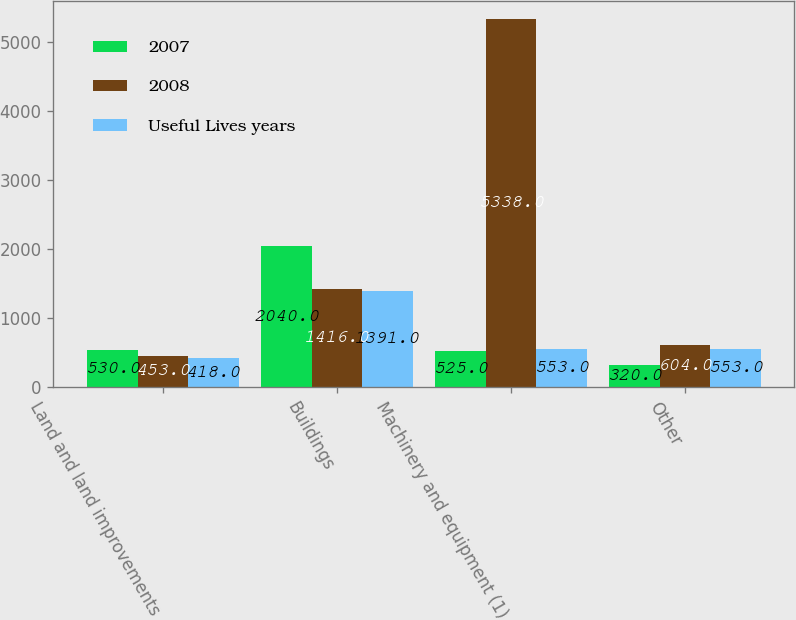Convert chart to OTSL. <chart><loc_0><loc_0><loc_500><loc_500><stacked_bar_chart><ecel><fcel>Land and land improvements<fcel>Buildings<fcel>Machinery and equipment (1)<fcel>Other<nl><fcel>2007<fcel>530<fcel>2040<fcel>525<fcel>320<nl><fcel>2008<fcel>453<fcel>1416<fcel>5338<fcel>604<nl><fcel>Useful Lives years<fcel>418<fcel>1391<fcel>553<fcel>553<nl></chart> 